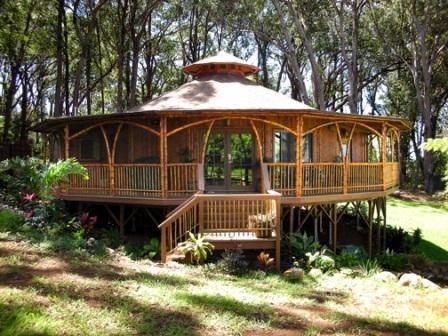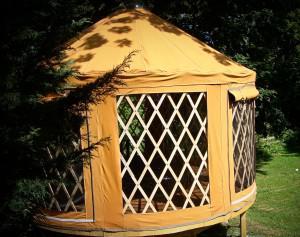The first image is the image on the left, the second image is the image on the right. Analyze the images presented: Is the assertion "There are stairs in the image on the left." valid? Answer yes or no. Yes. The first image is the image on the left, the second image is the image on the right. Examine the images to the left and right. Is the description "A white round house has a forward facing door and at least one window." accurate? Answer yes or no. No. 